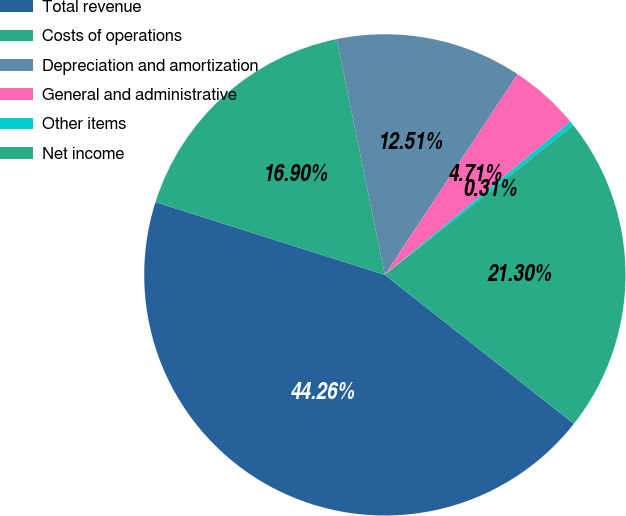<chart> <loc_0><loc_0><loc_500><loc_500><pie_chart><fcel>Total revenue<fcel>Costs of operations<fcel>Depreciation and amortization<fcel>General and administrative<fcel>Other items<fcel>Net income<nl><fcel>44.26%<fcel>16.9%<fcel>12.51%<fcel>4.71%<fcel>0.31%<fcel>21.3%<nl></chart> 